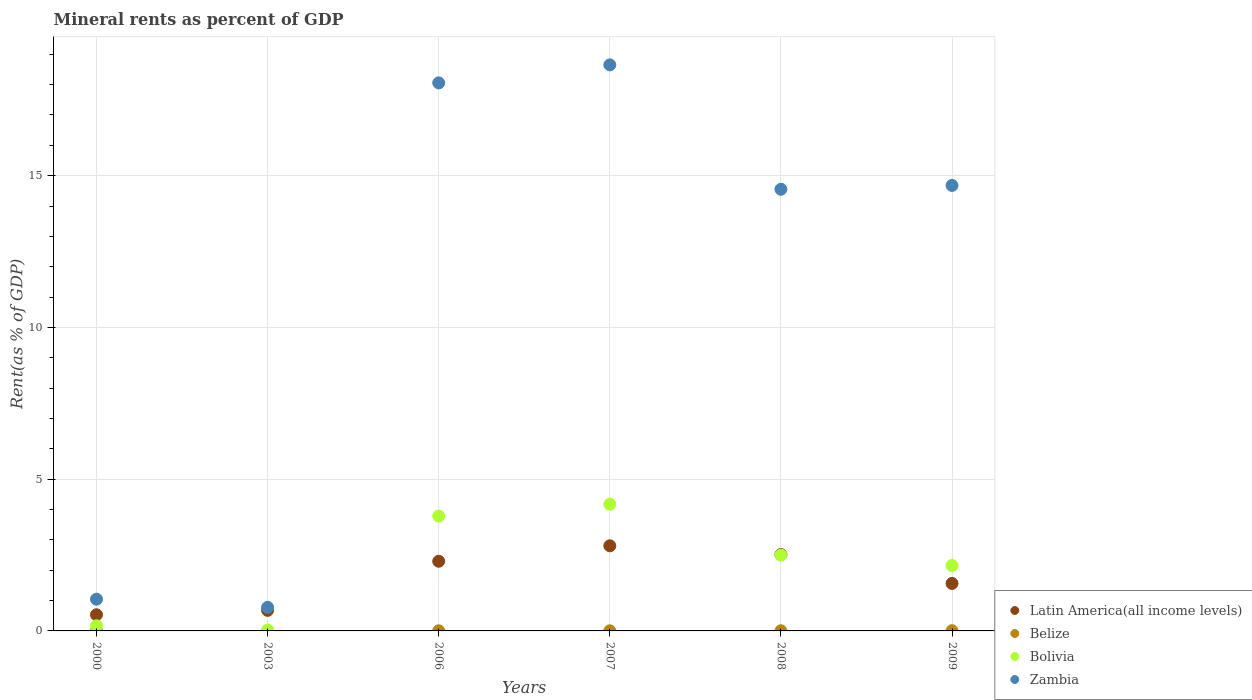How many different coloured dotlines are there?
Your answer should be compact. 4. Is the number of dotlines equal to the number of legend labels?
Your response must be concise. Yes. What is the mineral rent in Zambia in 2000?
Give a very brief answer. 1.04. Across all years, what is the maximum mineral rent in Zambia?
Your answer should be very brief. 18.65. Across all years, what is the minimum mineral rent in Zambia?
Make the answer very short. 0.78. In which year was the mineral rent in Bolivia maximum?
Ensure brevity in your answer.  2007. What is the total mineral rent in Zambia in the graph?
Give a very brief answer. 67.76. What is the difference between the mineral rent in Zambia in 2003 and that in 2006?
Provide a short and direct response. -17.28. What is the difference between the mineral rent in Latin America(all income levels) in 2006 and the mineral rent in Belize in 2007?
Your response must be concise. 2.29. What is the average mineral rent in Belize per year?
Your answer should be very brief. 0. In the year 2000, what is the difference between the mineral rent in Bolivia and mineral rent in Zambia?
Your response must be concise. -0.87. In how many years, is the mineral rent in Zambia greater than 13 %?
Make the answer very short. 4. What is the ratio of the mineral rent in Belize in 2008 to that in 2009?
Your answer should be very brief. 0.79. Is the mineral rent in Zambia in 2000 less than that in 2003?
Give a very brief answer. No. What is the difference between the highest and the second highest mineral rent in Latin America(all income levels)?
Provide a short and direct response. 0.29. What is the difference between the highest and the lowest mineral rent in Zambia?
Your answer should be compact. 17.87. In how many years, is the mineral rent in Bolivia greater than the average mineral rent in Bolivia taken over all years?
Offer a terse response. 4. Does the mineral rent in Bolivia monotonically increase over the years?
Keep it short and to the point. No. How many dotlines are there?
Provide a succinct answer. 4. What is the difference between two consecutive major ticks on the Y-axis?
Your answer should be very brief. 5. Are the values on the major ticks of Y-axis written in scientific E-notation?
Keep it short and to the point. No. Where does the legend appear in the graph?
Provide a succinct answer. Bottom right. How many legend labels are there?
Give a very brief answer. 4. What is the title of the graph?
Your answer should be very brief. Mineral rents as percent of GDP. What is the label or title of the Y-axis?
Make the answer very short. Rent(as % of GDP). What is the Rent(as % of GDP) of Latin America(all income levels) in 2000?
Ensure brevity in your answer.  0.53. What is the Rent(as % of GDP) in Belize in 2000?
Your response must be concise. 9.421557352848159e-5. What is the Rent(as % of GDP) of Bolivia in 2000?
Your response must be concise. 0.17. What is the Rent(as % of GDP) in Zambia in 2000?
Make the answer very short. 1.04. What is the Rent(as % of GDP) of Latin America(all income levels) in 2003?
Keep it short and to the point. 0.68. What is the Rent(as % of GDP) in Belize in 2003?
Offer a very short reply. 0. What is the Rent(as % of GDP) of Bolivia in 2003?
Your answer should be very brief. 0.03. What is the Rent(as % of GDP) of Zambia in 2003?
Provide a succinct answer. 0.78. What is the Rent(as % of GDP) of Latin America(all income levels) in 2006?
Provide a short and direct response. 2.3. What is the Rent(as % of GDP) of Belize in 2006?
Give a very brief answer. 0. What is the Rent(as % of GDP) of Bolivia in 2006?
Your response must be concise. 3.79. What is the Rent(as % of GDP) of Zambia in 2006?
Make the answer very short. 18.06. What is the Rent(as % of GDP) of Latin America(all income levels) in 2007?
Provide a succinct answer. 2.8. What is the Rent(as % of GDP) in Belize in 2007?
Offer a terse response. 0. What is the Rent(as % of GDP) of Bolivia in 2007?
Provide a short and direct response. 4.17. What is the Rent(as % of GDP) in Zambia in 2007?
Your answer should be compact. 18.65. What is the Rent(as % of GDP) of Latin America(all income levels) in 2008?
Your answer should be very brief. 2.52. What is the Rent(as % of GDP) in Belize in 2008?
Give a very brief answer. 0.01. What is the Rent(as % of GDP) of Bolivia in 2008?
Your answer should be very brief. 2.5. What is the Rent(as % of GDP) of Zambia in 2008?
Ensure brevity in your answer.  14.55. What is the Rent(as % of GDP) of Latin America(all income levels) in 2009?
Keep it short and to the point. 1.57. What is the Rent(as % of GDP) in Belize in 2009?
Ensure brevity in your answer.  0.01. What is the Rent(as % of GDP) in Bolivia in 2009?
Provide a short and direct response. 2.16. What is the Rent(as % of GDP) in Zambia in 2009?
Provide a succinct answer. 14.68. Across all years, what is the maximum Rent(as % of GDP) of Latin America(all income levels)?
Offer a terse response. 2.8. Across all years, what is the maximum Rent(as % of GDP) of Belize?
Offer a very short reply. 0.01. Across all years, what is the maximum Rent(as % of GDP) in Bolivia?
Give a very brief answer. 4.17. Across all years, what is the maximum Rent(as % of GDP) of Zambia?
Your answer should be compact. 18.65. Across all years, what is the minimum Rent(as % of GDP) in Latin America(all income levels)?
Give a very brief answer. 0.53. Across all years, what is the minimum Rent(as % of GDP) of Belize?
Your answer should be compact. 9.421557352848159e-5. Across all years, what is the minimum Rent(as % of GDP) in Bolivia?
Your answer should be very brief. 0.03. Across all years, what is the minimum Rent(as % of GDP) of Zambia?
Your answer should be very brief. 0.78. What is the total Rent(as % of GDP) of Latin America(all income levels) in the graph?
Give a very brief answer. 10.39. What is the total Rent(as % of GDP) in Belize in the graph?
Provide a short and direct response. 0.02. What is the total Rent(as % of GDP) of Bolivia in the graph?
Your response must be concise. 12.81. What is the total Rent(as % of GDP) in Zambia in the graph?
Provide a succinct answer. 67.76. What is the difference between the Rent(as % of GDP) in Latin America(all income levels) in 2000 and that in 2003?
Make the answer very short. -0.14. What is the difference between the Rent(as % of GDP) of Belize in 2000 and that in 2003?
Provide a succinct answer. -0. What is the difference between the Rent(as % of GDP) in Bolivia in 2000 and that in 2003?
Make the answer very short. 0.14. What is the difference between the Rent(as % of GDP) in Zambia in 2000 and that in 2003?
Your response must be concise. 0.27. What is the difference between the Rent(as % of GDP) of Latin America(all income levels) in 2000 and that in 2006?
Provide a succinct answer. -1.76. What is the difference between the Rent(as % of GDP) of Belize in 2000 and that in 2006?
Offer a very short reply. -0. What is the difference between the Rent(as % of GDP) in Bolivia in 2000 and that in 2006?
Make the answer very short. -3.62. What is the difference between the Rent(as % of GDP) in Zambia in 2000 and that in 2006?
Keep it short and to the point. -17.01. What is the difference between the Rent(as % of GDP) of Latin America(all income levels) in 2000 and that in 2007?
Ensure brevity in your answer.  -2.27. What is the difference between the Rent(as % of GDP) in Belize in 2000 and that in 2007?
Give a very brief answer. -0. What is the difference between the Rent(as % of GDP) of Bolivia in 2000 and that in 2007?
Your answer should be compact. -4. What is the difference between the Rent(as % of GDP) in Zambia in 2000 and that in 2007?
Offer a terse response. -17.61. What is the difference between the Rent(as % of GDP) of Latin America(all income levels) in 2000 and that in 2008?
Make the answer very short. -1.99. What is the difference between the Rent(as % of GDP) in Belize in 2000 and that in 2008?
Ensure brevity in your answer.  -0.01. What is the difference between the Rent(as % of GDP) in Bolivia in 2000 and that in 2008?
Make the answer very short. -2.33. What is the difference between the Rent(as % of GDP) of Zambia in 2000 and that in 2008?
Make the answer very short. -13.51. What is the difference between the Rent(as % of GDP) of Latin America(all income levels) in 2000 and that in 2009?
Your answer should be very brief. -1.03. What is the difference between the Rent(as % of GDP) in Belize in 2000 and that in 2009?
Keep it short and to the point. -0.01. What is the difference between the Rent(as % of GDP) of Bolivia in 2000 and that in 2009?
Provide a short and direct response. -1.99. What is the difference between the Rent(as % of GDP) of Zambia in 2000 and that in 2009?
Your answer should be compact. -13.63. What is the difference between the Rent(as % of GDP) of Latin America(all income levels) in 2003 and that in 2006?
Your answer should be compact. -1.62. What is the difference between the Rent(as % of GDP) of Belize in 2003 and that in 2006?
Offer a terse response. -0. What is the difference between the Rent(as % of GDP) in Bolivia in 2003 and that in 2006?
Give a very brief answer. -3.76. What is the difference between the Rent(as % of GDP) in Zambia in 2003 and that in 2006?
Provide a succinct answer. -17.28. What is the difference between the Rent(as % of GDP) in Latin America(all income levels) in 2003 and that in 2007?
Make the answer very short. -2.13. What is the difference between the Rent(as % of GDP) in Belize in 2003 and that in 2007?
Offer a terse response. -0. What is the difference between the Rent(as % of GDP) of Bolivia in 2003 and that in 2007?
Provide a succinct answer. -4.15. What is the difference between the Rent(as % of GDP) of Zambia in 2003 and that in 2007?
Offer a terse response. -17.87. What is the difference between the Rent(as % of GDP) in Latin America(all income levels) in 2003 and that in 2008?
Provide a succinct answer. -1.84. What is the difference between the Rent(as % of GDP) in Belize in 2003 and that in 2008?
Offer a terse response. -0.01. What is the difference between the Rent(as % of GDP) of Bolivia in 2003 and that in 2008?
Give a very brief answer. -2.47. What is the difference between the Rent(as % of GDP) in Zambia in 2003 and that in 2008?
Your response must be concise. -13.78. What is the difference between the Rent(as % of GDP) of Latin America(all income levels) in 2003 and that in 2009?
Provide a succinct answer. -0.89. What is the difference between the Rent(as % of GDP) of Belize in 2003 and that in 2009?
Offer a terse response. -0.01. What is the difference between the Rent(as % of GDP) in Bolivia in 2003 and that in 2009?
Your answer should be compact. -2.13. What is the difference between the Rent(as % of GDP) in Zambia in 2003 and that in 2009?
Ensure brevity in your answer.  -13.9. What is the difference between the Rent(as % of GDP) of Latin America(all income levels) in 2006 and that in 2007?
Give a very brief answer. -0.51. What is the difference between the Rent(as % of GDP) of Belize in 2006 and that in 2007?
Offer a very short reply. -0. What is the difference between the Rent(as % of GDP) in Bolivia in 2006 and that in 2007?
Offer a very short reply. -0.39. What is the difference between the Rent(as % of GDP) in Zambia in 2006 and that in 2007?
Offer a very short reply. -0.59. What is the difference between the Rent(as % of GDP) in Latin America(all income levels) in 2006 and that in 2008?
Your response must be concise. -0.22. What is the difference between the Rent(as % of GDP) of Belize in 2006 and that in 2008?
Keep it short and to the point. -0. What is the difference between the Rent(as % of GDP) in Bolivia in 2006 and that in 2008?
Your answer should be compact. 1.29. What is the difference between the Rent(as % of GDP) in Zambia in 2006 and that in 2008?
Make the answer very short. 3.51. What is the difference between the Rent(as % of GDP) in Latin America(all income levels) in 2006 and that in 2009?
Offer a terse response. 0.73. What is the difference between the Rent(as % of GDP) of Belize in 2006 and that in 2009?
Keep it short and to the point. -0. What is the difference between the Rent(as % of GDP) of Bolivia in 2006 and that in 2009?
Give a very brief answer. 1.63. What is the difference between the Rent(as % of GDP) in Zambia in 2006 and that in 2009?
Provide a succinct answer. 3.38. What is the difference between the Rent(as % of GDP) of Latin America(all income levels) in 2007 and that in 2008?
Your answer should be very brief. 0.29. What is the difference between the Rent(as % of GDP) in Belize in 2007 and that in 2008?
Offer a terse response. -0. What is the difference between the Rent(as % of GDP) in Bolivia in 2007 and that in 2008?
Keep it short and to the point. 1.68. What is the difference between the Rent(as % of GDP) in Zambia in 2007 and that in 2008?
Your answer should be very brief. 4.1. What is the difference between the Rent(as % of GDP) of Latin America(all income levels) in 2007 and that in 2009?
Your answer should be very brief. 1.24. What is the difference between the Rent(as % of GDP) in Belize in 2007 and that in 2009?
Your answer should be very brief. -0. What is the difference between the Rent(as % of GDP) in Bolivia in 2007 and that in 2009?
Give a very brief answer. 2.02. What is the difference between the Rent(as % of GDP) of Zambia in 2007 and that in 2009?
Offer a terse response. 3.97. What is the difference between the Rent(as % of GDP) of Latin America(all income levels) in 2008 and that in 2009?
Your response must be concise. 0.95. What is the difference between the Rent(as % of GDP) of Belize in 2008 and that in 2009?
Give a very brief answer. -0. What is the difference between the Rent(as % of GDP) in Bolivia in 2008 and that in 2009?
Offer a very short reply. 0.34. What is the difference between the Rent(as % of GDP) of Zambia in 2008 and that in 2009?
Provide a short and direct response. -0.13. What is the difference between the Rent(as % of GDP) of Latin America(all income levels) in 2000 and the Rent(as % of GDP) of Belize in 2003?
Offer a terse response. 0.53. What is the difference between the Rent(as % of GDP) in Latin America(all income levels) in 2000 and the Rent(as % of GDP) in Bolivia in 2003?
Make the answer very short. 0.5. What is the difference between the Rent(as % of GDP) of Latin America(all income levels) in 2000 and the Rent(as % of GDP) of Zambia in 2003?
Give a very brief answer. -0.24. What is the difference between the Rent(as % of GDP) in Belize in 2000 and the Rent(as % of GDP) in Bolivia in 2003?
Your answer should be compact. -0.03. What is the difference between the Rent(as % of GDP) of Belize in 2000 and the Rent(as % of GDP) of Zambia in 2003?
Keep it short and to the point. -0.78. What is the difference between the Rent(as % of GDP) of Bolivia in 2000 and the Rent(as % of GDP) of Zambia in 2003?
Offer a very short reply. -0.61. What is the difference between the Rent(as % of GDP) in Latin America(all income levels) in 2000 and the Rent(as % of GDP) in Belize in 2006?
Offer a very short reply. 0.53. What is the difference between the Rent(as % of GDP) of Latin America(all income levels) in 2000 and the Rent(as % of GDP) of Bolivia in 2006?
Your answer should be very brief. -3.25. What is the difference between the Rent(as % of GDP) of Latin America(all income levels) in 2000 and the Rent(as % of GDP) of Zambia in 2006?
Offer a terse response. -17.53. What is the difference between the Rent(as % of GDP) in Belize in 2000 and the Rent(as % of GDP) in Bolivia in 2006?
Your answer should be very brief. -3.79. What is the difference between the Rent(as % of GDP) in Belize in 2000 and the Rent(as % of GDP) in Zambia in 2006?
Ensure brevity in your answer.  -18.06. What is the difference between the Rent(as % of GDP) of Bolivia in 2000 and the Rent(as % of GDP) of Zambia in 2006?
Ensure brevity in your answer.  -17.89. What is the difference between the Rent(as % of GDP) in Latin America(all income levels) in 2000 and the Rent(as % of GDP) in Belize in 2007?
Provide a succinct answer. 0.53. What is the difference between the Rent(as % of GDP) in Latin America(all income levels) in 2000 and the Rent(as % of GDP) in Bolivia in 2007?
Make the answer very short. -3.64. What is the difference between the Rent(as % of GDP) in Latin America(all income levels) in 2000 and the Rent(as % of GDP) in Zambia in 2007?
Provide a succinct answer. -18.12. What is the difference between the Rent(as % of GDP) of Belize in 2000 and the Rent(as % of GDP) of Bolivia in 2007?
Your answer should be compact. -4.17. What is the difference between the Rent(as % of GDP) in Belize in 2000 and the Rent(as % of GDP) in Zambia in 2007?
Ensure brevity in your answer.  -18.65. What is the difference between the Rent(as % of GDP) of Bolivia in 2000 and the Rent(as % of GDP) of Zambia in 2007?
Your response must be concise. -18.48. What is the difference between the Rent(as % of GDP) in Latin America(all income levels) in 2000 and the Rent(as % of GDP) in Belize in 2008?
Offer a terse response. 0.53. What is the difference between the Rent(as % of GDP) in Latin America(all income levels) in 2000 and the Rent(as % of GDP) in Bolivia in 2008?
Offer a terse response. -1.97. What is the difference between the Rent(as % of GDP) of Latin America(all income levels) in 2000 and the Rent(as % of GDP) of Zambia in 2008?
Offer a very short reply. -14.02. What is the difference between the Rent(as % of GDP) of Belize in 2000 and the Rent(as % of GDP) of Bolivia in 2008?
Your answer should be compact. -2.5. What is the difference between the Rent(as % of GDP) in Belize in 2000 and the Rent(as % of GDP) in Zambia in 2008?
Offer a terse response. -14.55. What is the difference between the Rent(as % of GDP) of Bolivia in 2000 and the Rent(as % of GDP) of Zambia in 2008?
Your answer should be compact. -14.38. What is the difference between the Rent(as % of GDP) in Latin America(all income levels) in 2000 and the Rent(as % of GDP) in Belize in 2009?
Ensure brevity in your answer.  0.52. What is the difference between the Rent(as % of GDP) of Latin America(all income levels) in 2000 and the Rent(as % of GDP) of Bolivia in 2009?
Ensure brevity in your answer.  -1.62. What is the difference between the Rent(as % of GDP) of Latin America(all income levels) in 2000 and the Rent(as % of GDP) of Zambia in 2009?
Ensure brevity in your answer.  -14.15. What is the difference between the Rent(as % of GDP) in Belize in 2000 and the Rent(as % of GDP) in Bolivia in 2009?
Offer a terse response. -2.16. What is the difference between the Rent(as % of GDP) in Belize in 2000 and the Rent(as % of GDP) in Zambia in 2009?
Provide a short and direct response. -14.68. What is the difference between the Rent(as % of GDP) in Bolivia in 2000 and the Rent(as % of GDP) in Zambia in 2009?
Give a very brief answer. -14.51. What is the difference between the Rent(as % of GDP) in Latin America(all income levels) in 2003 and the Rent(as % of GDP) in Belize in 2006?
Your answer should be compact. 0.67. What is the difference between the Rent(as % of GDP) in Latin America(all income levels) in 2003 and the Rent(as % of GDP) in Bolivia in 2006?
Your answer should be compact. -3.11. What is the difference between the Rent(as % of GDP) in Latin America(all income levels) in 2003 and the Rent(as % of GDP) in Zambia in 2006?
Provide a succinct answer. -17.38. What is the difference between the Rent(as % of GDP) of Belize in 2003 and the Rent(as % of GDP) of Bolivia in 2006?
Give a very brief answer. -3.79. What is the difference between the Rent(as % of GDP) of Belize in 2003 and the Rent(as % of GDP) of Zambia in 2006?
Provide a succinct answer. -18.06. What is the difference between the Rent(as % of GDP) of Bolivia in 2003 and the Rent(as % of GDP) of Zambia in 2006?
Provide a succinct answer. -18.03. What is the difference between the Rent(as % of GDP) in Latin America(all income levels) in 2003 and the Rent(as % of GDP) in Belize in 2007?
Keep it short and to the point. 0.67. What is the difference between the Rent(as % of GDP) of Latin America(all income levels) in 2003 and the Rent(as % of GDP) of Bolivia in 2007?
Make the answer very short. -3.5. What is the difference between the Rent(as % of GDP) of Latin America(all income levels) in 2003 and the Rent(as % of GDP) of Zambia in 2007?
Provide a short and direct response. -17.97. What is the difference between the Rent(as % of GDP) in Belize in 2003 and the Rent(as % of GDP) in Bolivia in 2007?
Ensure brevity in your answer.  -4.17. What is the difference between the Rent(as % of GDP) in Belize in 2003 and the Rent(as % of GDP) in Zambia in 2007?
Ensure brevity in your answer.  -18.65. What is the difference between the Rent(as % of GDP) in Bolivia in 2003 and the Rent(as % of GDP) in Zambia in 2007?
Your response must be concise. -18.62. What is the difference between the Rent(as % of GDP) in Latin America(all income levels) in 2003 and the Rent(as % of GDP) in Belize in 2008?
Give a very brief answer. 0.67. What is the difference between the Rent(as % of GDP) in Latin America(all income levels) in 2003 and the Rent(as % of GDP) in Bolivia in 2008?
Make the answer very short. -1.82. What is the difference between the Rent(as % of GDP) of Latin America(all income levels) in 2003 and the Rent(as % of GDP) of Zambia in 2008?
Ensure brevity in your answer.  -13.88. What is the difference between the Rent(as % of GDP) in Belize in 2003 and the Rent(as % of GDP) in Bolivia in 2008?
Keep it short and to the point. -2.5. What is the difference between the Rent(as % of GDP) of Belize in 2003 and the Rent(as % of GDP) of Zambia in 2008?
Offer a terse response. -14.55. What is the difference between the Rent(as % of GDP) of Bolivia in 2003 and the Rent(as % of GDP) of Zambia in 2008?
Your answer should be very brief. -14.52. What is the difference between the Rent(as % of GDP) in Latin America(all income levels) in 2003 and the Rent(as % of GDP) in Belize in 2009?
Your answer should be very brief. 0.67. What is the difference between the Rent(as % of GDP) of Latin America(all income levels) in 2003 and the Rent(as % of GDP) of Bolivia in 2009?
Provide a short and direct response. -1.48. What is the difference between the Rent(as % of GDP) in Latin America(all income levels) in 2003 and the Rent(as % of GDP) in Zambia in 2009?
Ensure brevity in your answer.  -14. What is the difference between the Rent(as % of GDP) of Belize in 2003 and the Rent(as % of GDP) of Bolivia in 2009?
Your answer should be compact. -2.15. What is the difference between the Rent(as % of GDP) in Belize in 2003 and the Rent(as % of GDP) in Zambia in 2009?
Make the answer very short. -14.68. What is the difference between the Rent(as % of GDP) in Bolivia in 2003 and the Rent(as % of GDP) in Zambia in 2009?
Offer a very short reply. -14.65. What is the difference between the Rent(as % of GDP) in Latin America(all income levels) in 2006 and the Rent(as % of GDP) in Belize in 2007?
Your answer should be very brief. 2.29. What is the difference between the Rent(as % of GDP) in Latin America(all income levels) in 2006 and the Rent(as % of GDP) in Bolivia in 2007?
Give a very brief answer. -1.88. What is the difference between the Rent(as % of GDP) in Latin America(all income levels) in 2006 and the Rent(as % of GDP) in Zambia in 2007?
Provide a succinct answer. -16.36. What is the difference between the Rent(as % of GDP) of Belize in 2006 and the Rent(as % of GDP) of Bolivia in 2007?
Offer a terse response. -4.17. What is the difference between the Rent(as % of GDP) in Belize in 2006 and the Rent(as % of GDP) in Zambia in 2007?
Your answer should be compact. -18.65. What is the difference between the Rent(as % of GDP) of Bolivia in 2006 and the Rent(as % of GDP) of Zambia in 2007?
Offer a very short reply. -14.87. What is the difference between the Rent(as % of GDP) in Latin America(all income levels) in 2006 and the Rent(as % of GDP) in Belize in 2008?
Give a very brief answer. 2.29. What is the difference between the Rent(as % of GDP) of Latin America(all income levels) in 2006 and the Rent(as % of GDP) of Bolivia in 2008?
Ensure brevity in your answer.  -0.2. What is the difference between the Rent(as % of GDP) of Latin America(all income levels) in 2006 and the Rent(as % of GDP) of Zambia in 2008?
Your answer should be compact. -12.26. What is the difference between the Rent(as % of GDP) of Belize in 2006 and the Rent(as % of GDP) of Bolivia in 2008?
Provide a short and direct response. -2.5. What is the difference between the Rent(as % of GDP) in Belize in 2006 and the Rent(as % of GDP) in Zambia in 2008?
Offer a very short reply. -14.55. What is the difference between the Rent(as % of GDP) in Bolivia in 2006 and the Rent(as % of GDP) in Zambia in 2008?
Ensure brevity in your answer.  -10.77. What is the difference between the Rent(as % of GDP) in Latin America(all income levels) in 2006 and the Rent(as % of GDP) in Belize in 2009?
Your answer should be very brief. 2.29. What is the difference between the Rent(as % of GDP) in Latin America(all income levels) in 2006 and the Rent(as % of GDP) in Bolivia in 2009?
Your answer should be very brief. 0.14. What is the difference between the Rent(as % of GDP) in Latin America(all income levels) in 2006 and the Rent(as % of GDP) in Zambia in 2009?
Offer a terse response. -12.38. What is the difference between the Rent(as % of GDP) in Belize in 2006 and the Rent(as % of GDP) in Bolivia in 2009?
Your answer should be very brief. -2.15. What is the difference between the Rent(as % of GDP) of Belize in 2006 and the Rent(as % of GDP) of Zambia in 2009?
Your answer should be very brief. -14.67. What is the difference between the Rent(as % of GDP) in Bolivia in 2006 and the Rent(as % of GDP) in Zambia in 2009?
Your answer should be very brief. -10.89. What is the difference between the Rent(as % of GDP) of Latin America(all income levels) in 2007 and the Rent(as % of GDP) of Belize in 2008?
Provide a short and direct response. 2.8. What is the difference between the Rent(as % of GDP) in Latin America(all income levels) in 2007 and the Rent(as % of GDP) in Bolivia in 2008?
Offer a very short reply. 0.31. What is the difference between the Rent(as % of GDP) in Latin America(all income levels) in 2007 and the Rent(as % of GDP) in Zambia in 2008?
Ensure brevity in your answer.  -11.75. What is the difference between the Rent(as % of GDP) in Belize in 2007 and the Rent(as % of GDP) in Bolivia in 2008?
Offer a terse response. -2.49. What is the difference between the Rent(as % of GDP) of Belize in 2007 and the Rent(as % of GDP) of Zambia in 2008?
Provide a short and direct response. -14.55. What is the difference between the Rent(as % of GDP) of Bolivia in 2007 and the Rent(as % of GDP) of Zambia in 2008?
Offer a very short reply. -10.38. What is the difference between the Rent(as % of GDP) in Latin America(all income levels) in 2007 and the Rent(as % of GDP) in Belize in 2009?
Provide a succinct answer. 2.8. What is the difference between the Rent(as % of GDP) of Latin America(all income levels) in 2007 and the Rent(as % of GDP) of Bolivia in 2009?
Offer a terse response. 0.65. What is the difference between the Rent(as % of GDP) of Latin America(all income levels) in 2007 and the Rent(as % of GDP) of Zambia in 2009?
Keep it short and to the point. -11.87. What is the difference between the Rent(as % of GDP) in Belize in 2007 and the Rent(as % of GDP) in Bolivia in 2009?
Offer a very short reply. -2.15. What is the difference between the Rent(as % of GDP) in Belize in 2007 and the Rent(as % of GDP) in Zambia in 2009?
Your response must be concise. -14.67. What is the difference between the Rent(as % of GDP) of Bolivia in 2007 and the Rent(as % of GDP) of Zambia in 2009?
Provide a succinct answer. -10.5. What is the difference between the Rent(as % of GDP) in Latin America(all income levels) in 2008 and the Rent(as % of GDP) in Belize in 2009?
Your response must be concise. 2.51. What is the difference between the Rent(as % of GDP) in Latin America(all income levels) in 2008 and the Rent(as % of GDP) in Bolivia in 2009?
Provide a short and direct response. 0.36. What is the difference between the Rent(as % of GDP) of Latin America(all income levels) in 2008 and the Rent(as % of GDP) of Zambia in 2009?
Offer a very short reply. -12.16. What is the difference between the Rent(as % of GDP) in Belize in 2008 and the Rent(as % of GDP) in Bolivia in 2009?
Ensure brevity in your answer.  -2.15. What is the difference between the Rent(as % of GDP) in Belize in 2008 and the Rent(as % of GDP) in Zambia in 2009?
Offer a terse response. -14.67. What is the difference between the Rent(as % of GDP) of Bolivia in 2008 and the Rent(as % of GDP) of Zambia in 2009?
Your response must be concise. -12.18. What is the average Rent(as % of GDP) of Latin America(all income levels) per year?
Keep it short and to the point. 1.73. What is the average Rent(as % of GDP) of Belize per year?
Your answer should be very brief. 0. What is the average Rent(as % of GDP) in Bolivia per year?
Offer a very short reply. 2.14. What is the average Rent(as % of GDP) of Zambia per year?
Your response must be concise. 11.29. In the year 2000, what is the difference between the Rent(as % of GDP) of Latin America(all income levels) and Rent(as % of GDP) of Belize?
Make the answer very short. 0.53. In the year 2000, what is the difference between the Rent(as % of GDP) in Latin America(all income levels) and Rent(as % of GDP) in Bolivia?
Make the answer very short. 0.36. In the year 2000, what is the difference between the Rent(as % of GDP) of Latin America(all income levels) and Rent(as % of GDP) of Zambia?
Offer a very short reply. -0.51. In the year 2000, what is the difference between the Rent(as % of GDP) in Belize and Rent(as % of GDP) in Bolivia?
Your answer should be very brief. -0.17. In the year 2000, what is the difference between the Rent(as % of GDP) in Belize and Rent(as % of GDP) in Zambia?
Your response must be concise. -1.04. In the year 2000, what is the difference between the Rent(as % of GDP) of Bolivia and Rent(as % of GDP) of Zambia?
Offer a terse response. -0.87. In the year 2003, what is the difference between the Rent(as % of GDP) in Latin America(all income levels) and Rent(as % of GDP) in Belize?
Keep it short and to the point. 0.68. In the year 2003, what is the difference between the Rent(as % of GDP) of Latin America(all income levels) and Rent(as % of GDP) of Bolivia?
Your answer should be compact. 0.65. In the year 2003, what is the difference between the Rent(as % of GDP) of Latin America(all income levels) and Rent(as % of GDP) of Zambia?
Give a very brief answer. -0.1. In the year 2003, what is the difference between the Rent(as % of GDP) of Belize and Rent(as % of GDP) of Bolivia?
Ensure brevity in your answer.  -0.03. In the year 2003, what is the difference between the Rent(as % of GDP) in Belize and Rent(as % of GDP) in Zambia?
Your response must be concise. -0.78. In the year 2003, what is the difference between the Rent(as % of GDP) of Bolivia and Rent(as % of GDP) of Zambia?
Make the answer very short. -0.75. In the year 2006, what is the difference between the Rent(as % of GDP) in Latin America(all income levels) and Rent(as % of GDP) in Belize?
Make the answer very short. 2.29. In the year 2006, what is the difference between the Rent(as % of GDP) in Latin America(all income levels) and Rent(as % of GDP) in Bolivia?
Your response must be concise. -1.49. In the year 2006, what is the difference between the Rent(as % of GDP) in Latin America(all income levels) and Rent(as % of GDP) in Zambia?
Give a very brief answer. -15.76. In the year 2006, what is the difference between the Rent(as % of GDP) of Belize and Rent(as % of GDP) of Bolivia?
Your answer should be very brief. -3.78. In the year 2006, what is the difference between the Rent(as % of GDP) of Belize and Rent(as % of GDP) of Zambia?
Provide a succinct answer. -18.05. In the year 2006, what is the difference between the Rent(as % of GDP) of Bolivia and Rent(as % of GDP) of Zambia?
Give a very brief answer. -14.27. In the year 2007, what is the difference between the Rent(as % of GDP) of Latin America(all income levels) and Rent(as % of GDP) of Belize?
Your answer should be compact. 2.8. In the year 2007, what is the difference between the Rent(as % of GDP) in Latin America(all income levels) and Rent(as % of GDP) in Bolivia?
Your answer should be compact. -1.37. In the year 2007, what is the difference between the Rent(as % of GDP) in Latin America(all income levels) and Rent(as % of GDP) in Zambia?
Offer a terse response. -15.85. In the year 2007, what is the difference between the Rent(as % of GDP) of Belize and Rent(as % of GDP) of Bolivia?
Your answer should be very brief. -4.17. In the year 2007, what is the difference between the Rent(as % of GDP) of Belize and Rent(as % of GDP) of Zambia?
Offer a terse response. -18.65. In the year 2007, what is the difference between the Rent(as % of GDP) of Bolivia and Rent(as % of GDP) of Zambia?
Ensure brevity in your answer.  -14.48. In the year 2008, what is the difference between the Rent(as % of GDP) of Latin America(all income levels) and Rent(as % of GDP) of Belize?
Your answer should be very brief. 2.51. In the year 2008, what is the difference between the Rent(as % of GDP) in Latin America(all income levels) and Rent(as % of GDP) in Bolivia?
Give a very brief answer. 0.02. In the year 2008, what is the difference between the Rent(as % of GDP) in Latin America(all income levels) and Rent(as % of GDP) in Zambia?
Your answer should be compact. -12.04. In the year 2008, what is the difference between the Rent(as % of GDP) in Belize and Rent(as % of GDP) in Bolivia?
Keep it short and to the point. -2.49. In the year 2008, what is the difference between the Rent(as % of GDP) in Belize and Rent(as % of GDP) in Zambia?
Provide a short and direct response. -14.55. In the year 2008, what is the difference between the Rent(as % of GDP) in Bolivia and Rent(as % of GDP) in Zambia?
Make the answer very short. -12.05. In the year 2009, what is the difference between the Rent(as % of GDP) in Latin America(all income levels) and Rent(as % of GDP) in Belize?
Keep it short and to the point. 1.56. In the year 2009, what is the difference between the Rent(as % of GDP) in Latin America(all income levels) and Rent(as % of GDP) in Bolivia?
Keep it short and to the point. -0.59. In the year 2009, what is the difference between the Rent(as % of GDP) in Latin America(all income levels) and Rent(as % of GDP) in Zambia?
Give a very brief answer. -13.11. In the year 2009, what is the difference between the Rent(as % of GDP) of Belize and Rent(as % of GDP) of Bolivia?
Offer a very short reply. -2.15. In the year 2009, what is the difference between the Rent(as % of GDP) of Belize and Rent(as % of GDP) of Zambia?
Make the answer very short. -14.67. In the year 2009, what is the difference between the Rent(as % of GDP) of Bolivia and Rent(as % of GDP) of Zambia?
Your response must be concise. -12.52. What is the ratio of the Rent(as % of GDP) in Latin America(all income levels) in 2000 to that in 2003?
Your answer should be compact. 0.79. What is the ratio of the Rent(as % of GDP) in Belize in 2000 to that in 2003?
Your answer should be very brief. 0.33. What is the ratio of the Rent(as % of GDP) in Bolivia in 2000 to that in 2003?
Keep it short and to the point. 5.98. What is the ratio of the Rent(as % of GDP) in Zambia in 2000 to that in 2003?
Make the answer very short. 1.34. What is the ratio of the Rent(as % of GDP) in Latin America(all income levels) in 2000 to that in 2006?
Make the answer very short. 0.23. What is the ratio of the Rent(as % of GDP) of Belize in 2000 to that in 2006?
Provide a short and direct response. 0.02. What is the ratio of the Rent(as % of GDP) in Bolivia in 2000 to that in 2006?
Provide a short and direct response. 0.04. What is the ratio of the Rent(as % of GDP) in Zambia in 2000 to that in 2006?
Your answer should be very brief. 0.06. What is the ratio of the Rent(as % of GDP) of Latin America(all income levels) in 2000 to that in 2007?
Offer a terse response. 0.19. What is the ratio of the Rent(as % of GDP) in Belize in 2000 to that in 2007?
Offer a terse response. 0.02. What is the ratio of the Rent(as % of GDP) in Bolivia in 2000 to that in 2007?
Make the answer very short. 0.04. What is the ratio of the Rent(as % of GDP) of Zambia in 2000 to that in 2007?
Ensure brevity in your answer.  0.06. What is the ratio of the Rent(as % of GDP) of Latin America(all income levels) in 2000 to that in 2008?
Keep it short and to the point. 0.21. What is the ratio of the Rent(as % of GDP) of Belize in 2000 to that in 2008?
Keep it short and to the point. 0.02. What is the ratio of the Rent(as % of GDP) of Bolivia in 2000 to that in 2008?
Provide a short and direct response. 0.07. What is the ratio of the Rent(as % of GDP) of Zambia in 2000 to that in 2008?
Give a very brief answer. 0.07. What is the ratio of the Rent(as % of GDP) in Latin America(all income levels) in 2000 to that in 2009?
Offer a very short reply. 0.34. What is the ratio of the Rent(as % of GDP) of Belize in 2000 to that in 2009?
Make the answer very short. 0.01. What is the ratio of the Rent(as % of GDP) of Bolivia in 2000 to that in 2009?
Provide a short and direct response. 0.08. What is the ratio of the Rent(as % of GDP) in Zambia in 2000 to that in 2009?
Your answer should be very brief. 0.07. What is the ratio of the Rent(as % of GDP) in Latin America(all income levels) in 2003 to that in 2006?
Your answer should be compact. 0.29. What is the ratio of the Rent(as % of GDP) in Belize in 2003 to that in 2006?
Offer a very short reply. 0.07. What is the ratio of the Rent(as % of GDP) in Bolivia in 2003 to that in 2006?
Your answer should be very brief. 0.01. What is the ratio of the Rent(as % of GDP) in Zambia in 2003 to that in 2006?
Your answer should be very brief. 0.04. What is the ratio of the Rent(as % of GDP) of Latin America(all income levels) in 2003 to that in 2007?
Ensure brevity in your answer.  0.24. What is the ratio of the Rent(as % of GDP) in Belize in 2003 to that in 2007?
Ensure brevity in your answer.  0.06. What is the ratio of the Rent(as % of GDP) of Bolivia in 2003 to that in 2007?
Your answer should be very brief. 0.01. What is the ratio of the Rent(as % of GDP) in Zambia in 2003 to that in 2007?
Provide a succinct answer. 0.04. What is the ratio of the Rent(as % of GDP) of Latin America(all income levels) in 2003 to that in 2008?
Provide a succinct answer. 0.27. What is the ratio of the Rent(as % of GDP) of Belize in 2003 to that in 2008?
Your response must be concise. 0.05. What is the ratio of the Rent(as % of GDP) in Bolivia in 2003 to that in 2008?
Offer a terse response. 0.01. What is the ratio of the Rent(as % of GDP) of Zambia in 2003 to that in 2008?
Keep it short and to the point. 0.05. What is the ratio of the Rent(as % of GDP) in Latin America(all income levels) in 2003 to that in 2009?
Keep it short and to the point. 0.43. What is the ratio of the Rent(as % of GDP) of Belize in 2003 to that in 2009?
Offer a terse response. 0.04. What is the ratio of the Rent(as % of GDP) of Bolivia in 2003 to that in 2009?
Give a very brief answer. 0.01. What is the ratio of the Rent(as % of GDP) of Zambia in 2003 to that in 2009?
Ensure brevity in your answer.  0.05. What is the ratio of the Rent(as % of GDP) in Latin America(all income levels) in 2006 to that in 2007?
Your response must be concise. 0.82. What is the ratio of the Rent(as % of GDP) in Belize in 2006 to that in 2007?
Provide a succinct answer. 0.85. What is the ratio of the Rent(as % of GDP) of Bolivia in 2006 to that in 2007?
Offer a very short reply. 0.91. What is the ratio of the Rent(as % of GDP) of Zambia in 2006 to that in 2007?
Your response must be concise. 0.97. What is the ratio of the Rent(as % of GDP) of Latin America(all income levels) in 2006 to that in 2008?
Offer a very short reply. 0.91. What is the ratio of the Rent(as % of GDP) of Belize in 2006 to that in 2008?
Your answer should be very brief. 0.64. What is the ratio of the Rent(as % of GDP) in Bolivia in 2006 to that in 2008?
Provide a succinct answer. 1.51. What is the ratio of the Rent(as % of GDP) in Zambia in 2006 to that in 2008?
Offer a very short reply. 1.24. What is the ratio of the Rent(as % of GDP) of Latin America(all income levels) in 2006 to that in 2009?
Keep it short and to the point. 1.47. What is the ratio of the Rent(as % of GDP) of Belize in 2006 to that in 2009?
Your response must be concise. 0.5. What is the ratio of the Rent(as % of GDP) in Bolivia in 2006 to that in 2009?
Offer a very short reply. 1.76. What is the ratio of the Rent(as % of GDP) of Zambia in 2006 to that in 2009?
Give a very brief answer. 1.23. What is the ratio of the Rent(as % of GDP) of Latin America(all income levels) in 2007 to that in 2008?
Ensure brevity in your answer.  1.11. What is the ratio of the Rent(as % of GDP) of Belize in 2007 to that in 2008?
Ensure brevity in your answer.  0.75. What is the ratio of the Rent(as % of GDP) in Bolivia in 2007 to that in 2008?
Your answer should be very brief. 1.67. What is the ratio of the Rent(as % of GDP) in Zambia in 2007 to that in 2008?
Make the answer very short. 1.28. What is the ratio of the Rent(as % of GDP) of Latin America(all income levels) in 2007 to that in 2009?
Keep it short and to the point. 1.79. What is the ratio of the Rent(as % of GDP) of Belize in 2007 to that in 2009?
Provide a short and direct response. 0.59. What is the ratio of the Rent(as % of GDP) in Bolivia in 2007 to that in 2009?
Provide a short and direct response. 1.94. What is the ratio of the Rent(as % of GDP) in Zambia in 2007 to that in 2009?
Ensure brevity in your answer.  1.27. What is the ratio of the Rent(as % of GDP) of Latin America(all income levels) in 2008 to that in 2009?
Offer a terse response. 1.61. What is the ratio of the Rent(as % of GDP) of Belize in 2008 to that in 2009?
Your answer should be very brief. 0.79. What is the ratio of the Rent(as % of GDP) in Bolivia in 2008 to that in 2009?
Give a very brief answer. 1.16. What is the ratio of the Rent(as % of GDP) in Zambia in 2008 to that in 2009?
Provide a short and direct response. 0.99. What is the difference between the highest and the second highest Rent(as % of GDP) of Latin America(all income levels)?
Your response must be concise. 0.29. What is the difference between the highest and the second highest Rent(as % of GDP) of Belize?
Make the answer very short. 0. What is the difference between the highest and the second highest Rent(as % of GDP) of Bolivia?
Your response must be concise. 0.39. What is the difference between the highest and the second highest Rent(as % of GDP) of Zambia?
Offer a very short reply. 0.59. What is the difference between the highest and the lowest Rent(as % of GDP) in Latin America(all income levels)?
Provide a succinct answer. 2.27. What is the difference between the highest and the lowest Rent(as % of GDP) of Belize?
Your answer should be very brief. 0.01. What is the difference between the highest and the lowest Rent(as % of GDP) of Bolivia?
Keep it short and to the point. 4.15. What is the difference between the highest and the lowest Rent(as % of GDP) of Zambia?
Give a very brief answer. 17.87. 